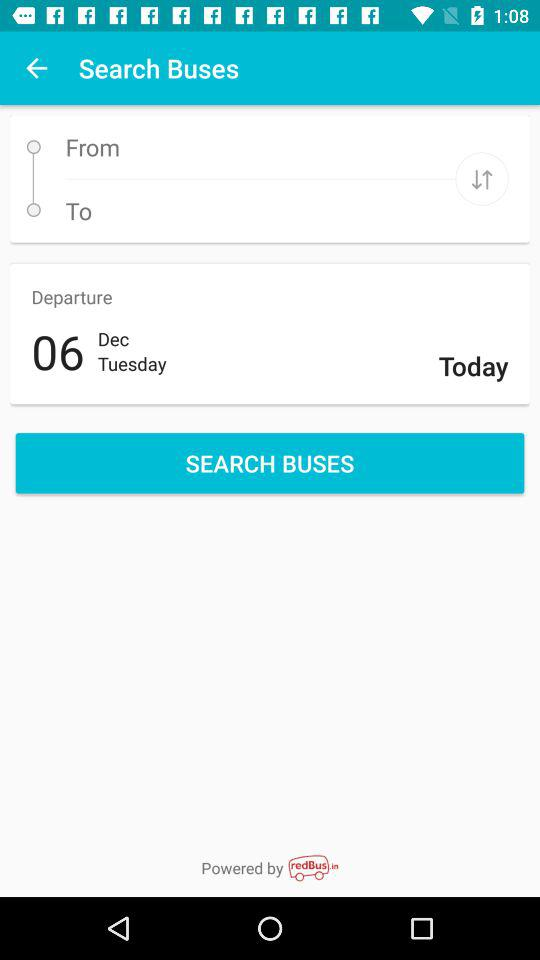What is the day of departure? The day of departure is Tuesday. 